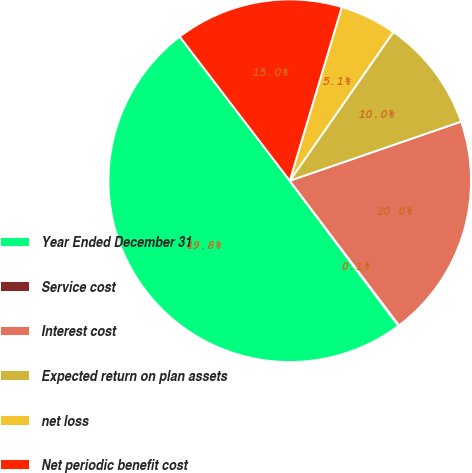<chart> <loc_0><loc_0><loc_500><loc_500><pie_chart><fcel>Year Ended December 31<fcel>Service cost<fcel>Interest cost<fcel>Expected return on plan assets<fcel>net loss<fcel>Net periodic benefit cost<nl><fcel>49.85%<fcel>0.07%<fcel>19.99%<fcel>10.03%<fcel>5.05%<fcel>15.01%<nl></chart> 